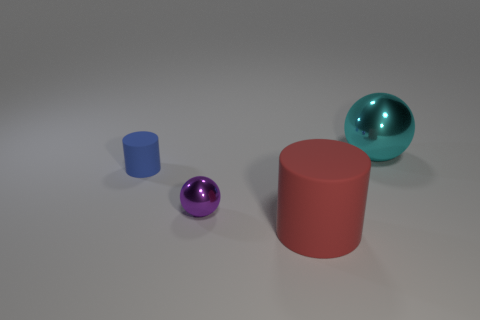The matte object that is to the left of the red cylinder has what shape? The object to the left of the red cylinder is a sphere with a matte blue surface, contrasting the red cylinder's glossy texture. 